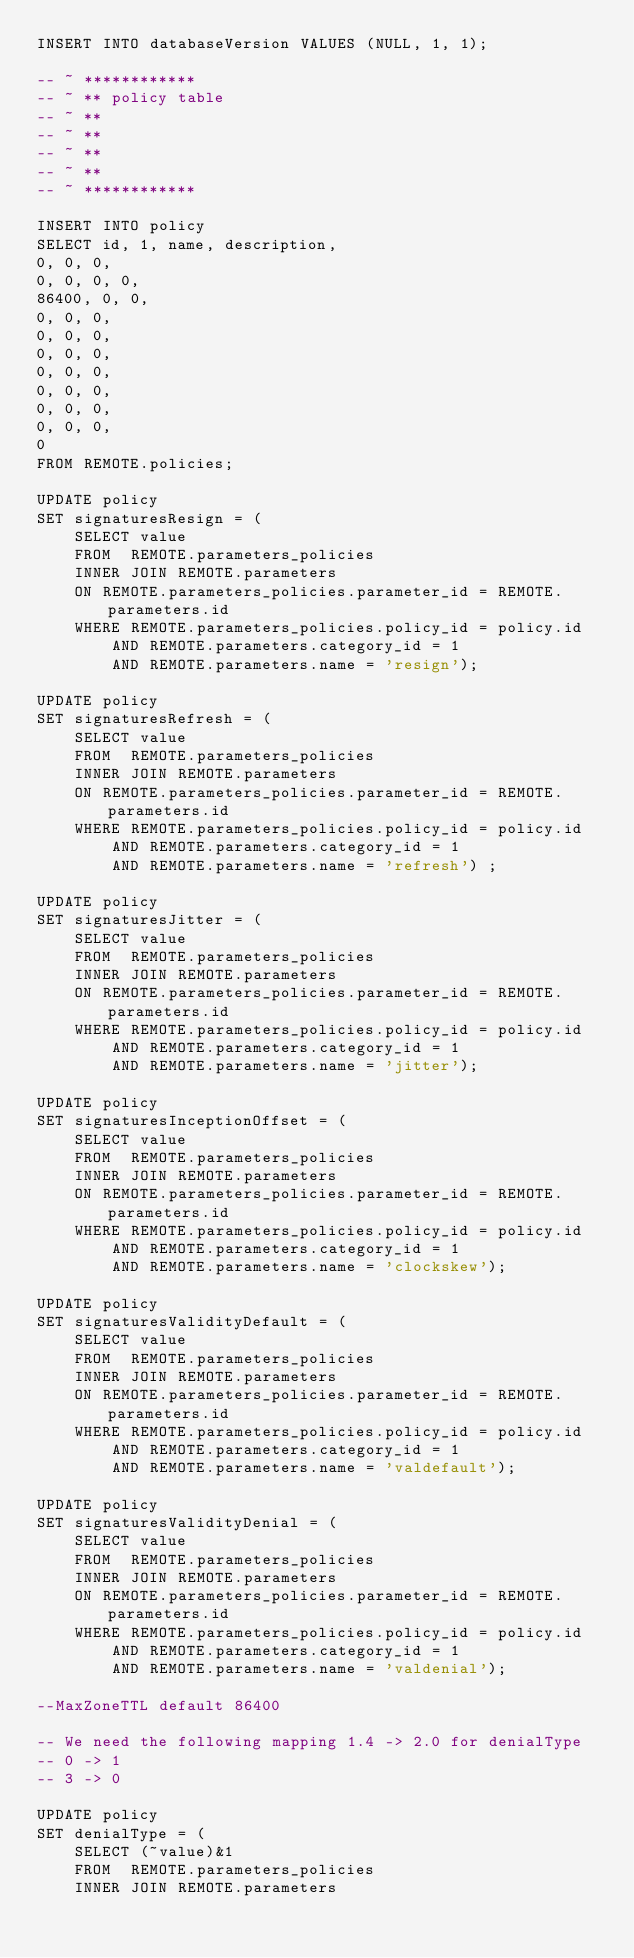Convert code to text. <code><loc_0><loc_0><loc_500><loc_500><_SQL_>INSERT INTO databaseVersion VALUES (NULL, 1, 1);

-- ~ ************
-- ~ ** policy table
-- ~ **
-- ~ **
-- ~ **
-- ~ **
-- ~ ************

INSERT INTO policy 
SELECT id, 1, name, description,
0, 0, 0,
0, 0, 0, 0,
86400, 0, 0,
0, 0, 0,
0, 0, 0,
0, 0, 0,
0, 0, 0,
0, 0, 0,
0, 0, 0,
0, 0, 0,
0
FROM REMOTE.policies;

UPDATE policy
SET signaturesResign = (
	SELECT value
	FROM  REMOTE.parameters_policies
	INNER JOIN REMOTE.parameters
	ON REMOTE.parameters_policies.parameter_id = REMOTE.parameters.id 
	WHERE REMOTE.parameters_policies.policy_id = policy.id 
		AND REMOTE.parameters.category_id = 1
		AND REMOTE.parameters.name = 'resign');

UPDATE policy
SET signaturesRefresh = (
	SELECT value
	FROM  REMOTE.parameters_policies
	INNER JOIN REMOTE.parameters
	ON REMOTE.parameters_policies.parameter_id = REMOTE.parameters.id 
	WHERE REMOTE.parameters_policies.policy_id = policy.id 
		AND REMOTE.parameters.category_id = 1
		AND REMOTE.parameters.name = 'refresh') ;

UPDATE policy
SET signaturesJitter = (
	SELECT value
	FROM  REMOTE.parameters_policies
	INNER JOIN REMOTE.parameters
	ON REMOTE.parameters_policies.parameter_id = REMOTE.parameters.id 
	WHERE REMOTE.parameters_policies.policy_id = policy.id 
		AND REMOTE.parameters.category_id = 1
		AND REMOTE.parameters.name = 'jitter');

UPDATE policy
SET signaturesInceptionOffset = (
	SELECT value
	FROM  REMOTE.parameters_policies
	INNER JOIN REMOTE.parameters
	ON REMOTE.parameters_policies.parameter_id = REMOTE.parameters.id 
	WHERE REMOTE.parameters_policies.policy_id = policy.id 
		AND REMOTE.parameters.category_id = 1
		AND REMOTE.parameters.name = 'clockskew');

UPDATE policy
SET signaturesValidityDefault = (
	SELECT value
	FROM  REMOTE.parameters_policies
	INNER JOIN REMOTE.parameters
	ON REMOTE.parameters_policies.parameter_id = REMOTE.parameters.id 
	WHERE REMOTE.parameters_policies.policy_id = policy.id 
		AND REMOTE.parameters.category_id = 1
		AND REMOTE.parameters.name = 'valdefault');

UPDATE policy
SET signaturesValidityDenial = (
	SELECT value
	FROM  REMOTE.parameters_policies
	INNER JOIN REMOTE.parameters
	ON REMOTE.parameters_policies.parameter_id = REMOTE.parameters.id 
	WHERE REMOTE.parameters_policies.policy_id = policy.id 
		AND REMOTE.parameters.category_id = 1
		AND REMOTE.parameters.name = 'valdenial');

--MaxZoneTTL default 86400

-- We need the following mapping 1.4 -> 2.0 for denialType
-- 0 -> 1
-- 3 -> 0

UPDATE policy
SET denialType = (
	SELECT (~value)&1
	FROM  REMOTE.parameters_policies
	INNER JOIN REMOTE.parameters</code> 